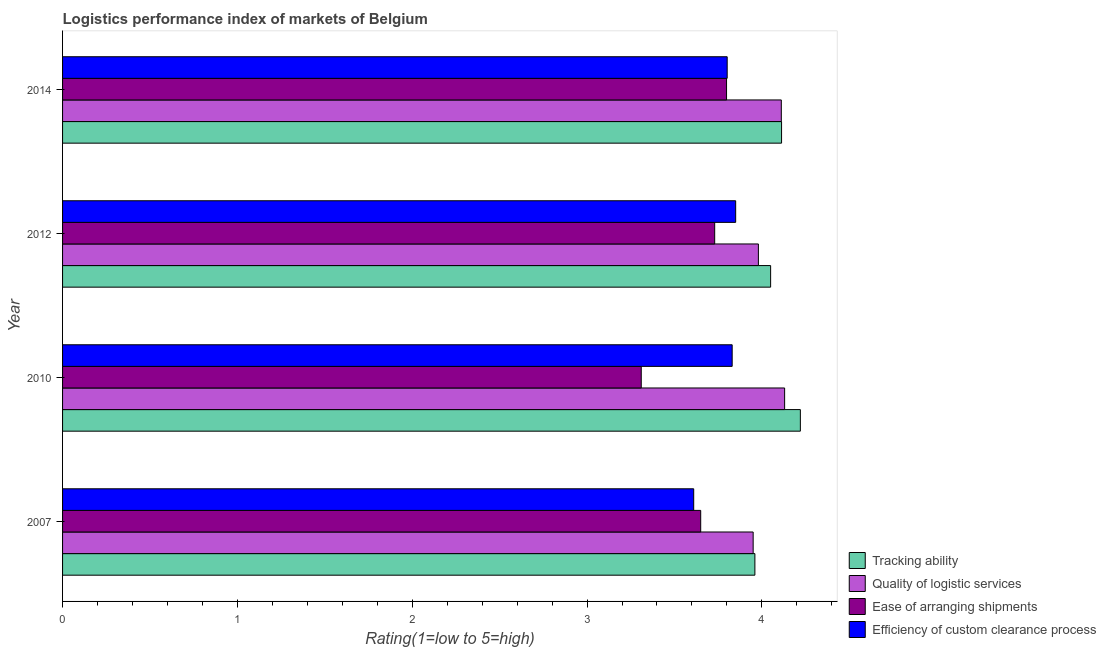Are the number of bars per tick equal to the number of legend labels?
Your answer should be compact. Yes. Are the number of bars on each tick of the Y-axis equal?
Ensure brevity in your answer.  Yes. How many bars are there on the 2nd tick from the bottom?
Provide a succinct answer. 4. In how many cases, is the number of bars for a given year not equal to the number of legend labels?
Offer a terse response. 0. What is the lpi rating of ease of arranging shipments in 2014?
Ensure brevity in your answer.  3.8. Across all years, what is the maximum lpi rating of quality of logistic services?
Provide a succinct answer. 4.13. Across all years, what is the minimum lpi rating of ease of arranging shipments?
Provide a succinct answer. 3.31. In which year was the lpi rating of ease of arranging shipments minimum?
Ensure brevity in your answer.  2010. What is the total lpi rating of quality of logistic services in the graph?
Give a very brief answer. 16.17. What is the difference between the lpi rating of quality of logistic services in 2007 and that in 2012?
Offer a terse response. -0.03. What is the difference between the lpi rating of ease of arranging shipments in 2014 and the lpi rating of tracking ability in 2007?
Make the answer very short. -0.16. What is the average lpi rating of quality of logistic services per year?
Your answer should be very brief. 4.04. In the year 2012, what is the difference between the lpi rating of efficiency of custom clearance process and lpi rating of quality of logistic services?
Make the answer very short. -0.13. In how many years, is the lpi rating of ease of arranging shipments greater than 1.2 ?
Offer a terse response. 4. What is the ratio of the lpi rating of tracking ability in 2010 to that in 2014?
Give a very brief answer. 1.03. Is the difference between the lpi rating of efficiency of custom clearance process in 2012 and 2014 greater than the difference between the lpi rating of ease of arranging shipments in 2012 and 2014?
Your answer should be compact. Yes. What is the difference between the highest and the second highest lpi rating of efficiency of custom clearance process?
Give a very brief answer. 0.02. What is the difference between the highest and the lowest lpi rating of ease of arranging shipments?
Ensure brevity in your answer.  0.49. In how many years, is the lpi rating of tracking ability greater than the average lpi rating of tracking ability taken over all years?
Make the answer very short. 2. Is the sum of the lpi rating of ease of arranging shipments in 2010 and 2014 greater than the maximum lpi rating of tracking ability across all years?
Your answer should be compact. Yes. What does the 4th bar from the top in 2010 represents?
Provide a short and direct response. Tracking ability. What does the 1st bar from the bottom in 2012 represents?
Give a very brief answer. Tracking ability. Is it the case that in every year, the sum of the lpi rating of tracking ability and lpi rating of quality of logistic services is greater than the lpi rating of ease of arranging shipments?
Offer a terse response. Yes. How many bars are there?
Offer a very short reply. 16. How many years are there in the graph?
Offer a terse response. 4. What is the difference between two consecutive major ticks on the X-axis?
Offer a very short reply. 1. Are the values on the major ticks of X-axis written in scientific E-notation?
Provide a short and direct response. No. How many legend labels are there?
Give a very brief answer. 4. What is the title of the graph?
Ensure brevity in your answer.  Logistics performance index of markets of Belgium. What is the label or title of the X-axis?
Give a very brief answer. Rating(1=low to 5=high). What is the label or title of the Y-axis?
Give a very brief answer. Year. What is the Rating(1=low to 5=high) in Tracking ability in 2007?
Provide a short and direct response. 3.96. What is the Rating(1=low to 5=high) of Quality of logistic services in 2007?
Provide a short and direct response. 3.95. What is the Rating(1=low to 5=high) in Ease of arranging shipments in 2007?
Give a very brief answer. 3.65. What is the Rating(1=low to 5=high) of Efficiency of custom clearance process in 2007?
Provide a short and direct response. 3.61. What is the Rating(1=low to 5=high) of Tracking ability in 2010?
Make the answer very short. 4.22. What is the Rating(1=low to 5=high) in Quality of logistic services in 2010?
Ensure brevity in your answer.  4.13. What is the Rating(1=low to 5=high) in Ease of arranging shipments in 2010?
Your answer should be very brief. 3.31. What is the Rating(1=low to 5=high) of Efficiency of custom clearance process in 2010?
Offer a very short reply. 3.83. What is the Rating(1=low to 5=high) in Tracking ability in 2012?
Offer a very short reply. 4.05. What is the Rating(1=low to 5=high) of Quality of logistic services in 2012?
Give a very brief answer. 3.98. What is the Rating(1=low to 5=high) of Ease of arranging shipments in 2012?
Your response must be concise. 3.73. What is the Rating(1=low to 5=high) in Efficiency of custom clearance process in 2012?
Offer a terse response. 3.85. What is the Rating(1=low to 5=high) in Tracking ability in 2014?
Your answer should be very brief. 4.11. What is the Rating(1=low to 5=high) of Quality of logistic services in 2014?
Give a very brief answer. 4.11. What is the Rating(1=low to 5=high) in Ease of arranging shipments in 2014?
Your answer should be very brief. 3.8. What is the Rating(1=low to 5=high) in Efficiency of custom clearance process in 2014?
Provide a succinct answer. 3.8. Across all years, what is the maximum Rating(1=low to 5=high) of Tracking ability?
Provide a succinct answer. 4.22. Across all years, what is the maximum Rating(1=low to 5=high) of Quality of logistic services?
Your answer should be compact. 4.13. Across all years, what is the maximum Rating(1=low to 5=high) of Ease of arranging shipments?
Make the answer very short. 3.8. Across all years, what is the maximum Rating(1=low to 5=high) in Efficiency of custom clearance process?
Your answer should be compact. 3.85. Across all years, what is the minimum Rating(1=low to 5=high) in Tracking ability?
Offer a very short reply. 3.96. Across all years, what is the minimum Rating(1=low to 5=high) of Quality of logistic services?
Your response must be concise. 3.95. Across all years, what is the minimum Rating(1=low to 5=high) in Ease of arranging shipments?
Your response must be concise. 3.31. Across all years, what is the minimum Rating(1=low to 5=high) in Efficiency of custom clearance process?
Offer a terse response. 3.61. What is the total Rating(1=low to 5=high) of Tracking ability in the graph?
Provide a short and direct response. 16.34. What is the total Rating(1=low to 5=high) in Quality of logistic services in the graph?
Give a very brief answer. 16.17. What is the total Rating(1=low to 5=high) in Ease of arranging shipments in the graph?
Offer a very short reply. 14.49. What is the total Rating(1=low to 5=high) of Efficiency of custom clearance process in the graph?
Make the answer very short. 15.09. What is the difference between the Rating(1=low to 5=high) in Tracking ability in 2007 and that in 2010?
Make the answer very short. -0.26. What is the difference between the Rating(1=low to 5=high) of Quality of logistic services in 2007 and that in 2010?
Ensure brevity in your answer.  -0.18. What is the difference between the Rating(1=low to 5=high) of Ease of arranging shipments in 2007 and that in 2010?
Keep it short and to the point. 0.34. What is the difference between the Rating(1=low to 5=high) in Efficiency of custom clearance process in 2007 and that in 2010?
Ensure brevity in your answer.  -0.22. What is the difference between the Rating(1=low to 5=high) of Tracking ability in 2007 and that in 2012?
Make the answer very short. -0.09. What is the difference between the Rating(1=low to 5=high) of Quality of logistic services in 2007 and that in 2012?
Give a very brief answer. -0.03. What is the difference between the Rating(1=low to 5=high) of Ease of arranging shipments in 2007 and that in 2012?
Make the answer very short. -0.08. What is the difference between the Rating(1=low to 5=high) of Efficiency of custom clearance process in 2007 and that in 2012?
Keep it short and to the point. -0.24. What is the difference between the Rating(1=low to 5=high) of Tracking ability in 2007 and that in 2014?
Provide a short and direct response. -0.15. What is the difference between the Rating(1=low to 5=high) of Quality of logistic services in 2007 and that in 2014?
Your answer should be very brief. -0.16. What is the difference between the Rating(1=low to 5=high) of Ease of arranging shipments in 2007 and that in 2014?
Your response must be concise. -0.15. What is the difference between the Rating(1=low to 5=high) of Efficiency of custom clearance process in 2007 and that in 2014?
Give a very brief answer. -0.19. What is the difference between the Rating(1=low to 5=high) of Tracking ability in 2010 and that in 2012?
Make the answer very short. 0.17. What is the difference between the Rating(1=low to 5=high) of Quality of logistic services in 2010 and that in 2012?
Offer a terse response. 0.15. What is the difference between the Rating(1=low to 5=high) in Ease of arranging shipments in 2010 and that in 2012?
Make the answer very short. -0.42. What is the difference between the Rating(1=low to 5=high) of Efficiency of custom clearance process in 2010 and that in 2012?
Offer a very short reply. -0.02. What is the difference between the Rating(1=low to 5=high) in Tracking ability in 2010 and that in 2014?
Keep it short and to the point. 0.11. What is the difference between the Rating(1=low to 5=high) in Quality of logistic services in 2010 and that in 2014?
Your answer should be compact. 0.02. What is the difference between the Rating(1=low to 5=high) in Ease of arranging shipments in 2010 and that in 2014?
Your response must be concise. -0.49. What is the difference between the Rating(1=low to 5=high) in Efficiency of custom clearance process in 2010 and that in 2014?
Make the answer very short. 0.03. What is the difference between the Rating(1=low to 5=high) in Tracking ability in 2012 and that in 2014?
Your answer should be very brief. -0.06. What is the difference between the Rating(1=low to 5=high) of Quality of logistic services in 2012 and that in 2014?
Provide a succinct answer. -0.13. What is the difference between the Rating(1=low to 5=high) of Ease of arranging shipments in 2012 and that in 2014?
Your answer should be compact. -0.07. What is the difference between the Rating(1=low to 5=high) of Efficiency of custom clearance process in 2012 and that in 2014?
Your response must be concise. 0.05. What is the difference between the Rating(1=low to 5=high) in Tracking ability in 2007 and the Rating(1=low to 5=high) in Quality of logistic services in 2010?
Your answer should be compact. -0.17. What is the difference between the Rating(1=low to 5=high) in Tracking ability in 2007 and the Rating(1=low to 5=high) in Ease of arranging shipments in 2010?
Ensure brevity in your answer.  0.65. What is the difference between the Rating(1=low to 5=high) in Tracking ability in 2007 and the Rating(1=low to 5=high) in Efficiency of custom clearance process in 2010?
Your answer should be very brief. 0.13. What is the difference between the Rating(1=low to 5=high) in Quality of logistic services in 2007 and the Rating(1=low to 5=high) in Ease of arranging shipments in 2010?
Provide a succinct answer. 0.64. What is the difference between the Rating(1=low to 5=high) of Quality of logistic services in 2007 and the Rating(1=low to 5=high) of Efficiency of custom clearance process in 2010?
Provide a short and direct response. 0.12. What is the difference between the Rating(1=low to 5=high) in Ease of arranging shipments in 2007 and the Rating(1=low to 5=high) in Efficiency of custom clearance process in 2010?
Make the answer very short. -0.18. What is the difference between the Rating(1=low to 5=high) in Tracking ability in 2007 and the Rating(1=low to 5=high) in Quality of logistic services in 2012?
Your answer should be compact. -0.02. What is the difference between the Rating(1=low to 5=high) in Tracking ability in 2007 and the Rating(1=low to 5=high) in Ease of arranging shipments in 2012?
Provide a succinct answer. 0.23. What is the difference between the Rating(1=low to 5=high) of Tracking ability in 2007 and the Rating(1=low to 5=high) of Efficiency of custom clearance process in 2012?
Your answer should be very brief. 0.11. What is the difference between the Rating(1=low to 5=high) of Quality of logistic services in 2007 and the Rating(1=low to 5=high) of Ease of arranging shipments in 2012?
Give a very brief answer. 0.22. What is the difference between the Rating(1=low to 5=high) in Tracking ability in 2007 and the Rating(1=low to 5=high) in Quality of logistic services in 2014?
Provide a succinct answer. -0.15. What is the difference between the Rating(1=low to 5=high) in Tracking ability in 2007 and the Rating(1=low to 5=high) in Ease of arranging shipments in 2014?
Make the answer very short. 0.16. What is the difference between the Rating(1=low to 5=high) of Tracking ability in 2007 and the Rating(1=low to 5=high) of Efficiency of custom clearance process in 2014?
Your answer should be compact. 0.16. What is the difference between the Rating(1=low to 5=high) of Quality of logistic services in 2007 and the Rating(1=low to 5=high) of Ease of arranging shipments in 2014?
Provide a short and direct response. 0.15. What is the difference between the Rating(1=low to 5=high) in Quality of logistic services in 2007 and the Rating(1=low to 5=high) in Efficiency of custom clearance process in 2014?
Ensure brevity in your answer.  0.15. What is the difference between the Rating(1=low to 5=high) in Ease of arranging shipments in 2007 and the Rating(1=low to 5=high) in Efficiency of custom clearance process in 2014?
Your answer should be compact. -0.15. What is the difference between the Rating(1=low to 5=high) in Tracking ability in 2010 and the Rating(1=low to 5=high) in Quality of logistic services in 2012?
Ensure brevity in your answer.  0.24. What is the difference between the Rating(1=low to 5=high) of Tracking ability in 2010 and the Rating(1=low to 5=high) of Ease of arranging shipments in 2012?
Your response must be concise. 0.49. What is the difference between the Rating(1=low to 5=high) in Tracking ability in 2010 and the Rating(1=low to 5=high) in Efficiency of custom clearance process in 2012?
Your answer should be very brief. 0.37. What is the difference between the Rating(1=low to 5=high) in Quality of logistic services in 2010 and the Rating(1=low to 5=high) in Efficiency of custom clearance process in 2012?
Offer a terse response. 0.28. What is the difference between the Rating(1=low to 5=high) of Ease of arranging shipments in 2010 and the Rating(1=low to 5=high) of Efficiency of custom clearance process in 2012?
Ensure brevity in your answer.  -0.54. What is the difference between the Rating(1=low to 5=high) in Tracking ability in 2010 and the Rating(1=low to 5=high) in Quality of logistic services in 2014?
Offer a terse response. 0.11. What is the difference between the Rating(1=low to 5=high) in Tracking ability in 2010 and the Rating(1=low to 5=high) in Ease of arranging shipments in 2014?
Your response must be concise. 0.42. What is the difference between the Rating(1=low to 5=high) in Tracking ability in 2010 and the Rating(1=low to 5=high) in Efficiency of custom clearance process in 2014?
Offer a terse response. 0.42. What is the difference between the Rating(1=low to 5=high) of Quality of logistic services in 2010 and the Rating(1=low to 5=high) of Ease of arranging shipments in 2014?
Provide a short and direct response. 0.33. What is the difference between the Rating(1=low to 5=high) of Quality of logistic services in 2010 and the Rating(1=low to 5=high) of Efficiency of custom clearance process in 2014?
Your answer should be compact. 0.33. What is the difference between the Rating(1=low to 5=high) in Ease of arranging shipments in 2010 and the Rating(1=low to 5=high) in Efficiency of custom clearance process in 2014?
Your response must be concise. -0.49. What is the difference between the Rating(1=low to 5=high) of Tracking ability in 2012 and the Rating(1=low to 5=high) of Quality of logistic services in 2014?
Keep it short and to the point. -0.06. What is the difference between the Rating(1=low to 5=high) of Tracking ability in 2012 and the Rating(1=low to 5=high) of Ease of arranging shipments in 2014?
Your answer should be very brief. 0.25. What is the difference between the Rating(1=low to 5=high) in Tracking ability in 2012 and the Rating(1=low to 5=high) in Efficiency of custom clearance process in 2014?
Offer a terse response. 0.25. What is the difference between the Rating(1=low to 5=high) of Quality of logistic services in 2012 and the Rating(1=low to 5=high) of Ease of arranging shipments in 2014?
Offer a very short reply. 0.18. What is the difference between the Rating(1=low to 5=high) of Quality of logistic services in 2012 and the Rating(1=low to 5=high) of Efficiency of custom clearance process in 2014?
Offer a very short reply. 0.18. What is the difference between the Rating(1=low to 5=high) in Ease of arranging shipments in 2012 and the Rating(1=low to 5=high) in Efficiency of custom clearance process in 2014?
Ensure brevity in your answer.  -0.07. What is the average Rating(1=low to 5=high) of Tracking ability per year?
Give a very brief answer. 4.09. What is the average Rating(1=low to 5=high) of Quality of logistic services per year?
Provide a succinct answer. 4.04. What is the average Rating(1=low to 5=high) of Ease of arranging shipments per year?
Your response must be concise. 3.62. What is the average Rating(1=low to 5=high) of Efficiency of custom clearance process per year?
Offer a terse response. 3.77. In the year 2007, what is the difference between the Rating(1=low to 5=high) of Tracking ability and Rating(1=low to 5=high) of Quality of logistic services?
Offer a very short reply. 0.01. In the year 2007, what is the difference between the Rating(1=low to 5=high) in Tracking ability and Rating(1=low to 5=high) in Ease of arranging shipments?
Make the answer very short. 0.31. In the year 2007, what is the difference between the Rating(1=low to 5=high) in Quality of logistic services and Rating(1=low to 5=high) in Efficiency of custom clearance process?
Your answer should be compact. 0.34. In the year 2007, what is the difference between the Rating(1=low to 5=high) in Ease of arranging shipments and Rating(1=low to 5=high) in Efficiency of custom clearance process?
Make the answer very short. 0.04. In the year 2010, what is the difference between the Rating(1=low to 5=high) in Tracking ability and Rating(1=low to 5=high) in Quality of logistic services?
Provide a succinct answer. 0.09. In the year 2010, what is the difference between the Rating(1=low to 5=high) of Tracking ability and Rating(1=low to 5=high) of Ease of arranging shipments?
Your response must be concise. 0.91. In the year 2010, what is the difference between the Rating(1=low to 5=high) in Tracking ability and Rating(1=low to 5=high) in Efficiency of custom clearance process?
Keep it short and to the point. 0.39. In the year 2010, what is the difference between the Rating(1=low to 5=high) in Quality of logistic services and Rating(1=low to 5=high) in Ease of arranging shipments?
Your answer should be very brief. 0.82. In the year 2010, what is the difference between the Rating(1=low to 5=high) in Ease of arranging shipments and Rating(1=low to 5=high) in Efficiency of custom clearance process?
Keep it short and to the point. -0.52. In the year 2012, what is the difference between the Rating(1=low to 5=high) in Tracking ability and Rating(1=low to 5=high) in Quality of logistic services?
Give a very brief answer. 0.07. In the year 2012, what is the difference between the Rating(1=low to 5=high) of Tracking ability and Rating(1=low to 5=high) of Ease of arranging shipments?
Offer a terse response. 0.32. In the year 2012, what is the difference between the Rating(1=low to 5=high) in Tracking ability and Rating(1=low to 5=high) in Efficiency of custom clearance process?
Your response must be concise. 0.2. In the year 2012, what is the difference between the Rating(1=low to 5=high) in Quality of logistic services and Rating(1=low to 5=high) in Efficiency of custom clearance process?
Make the answer very short. 0.13. In the year 2012, what is the difference between the Rating(1=low to 5=high) of Ease of arranging shipments and Rating(1=low to 5=high) of Efficiency of custom clearance process?
Your answer should be compact. -0.12. In the year 2014, what is the difference between the Rating(1=low to 5=high) in Tracking ability and Rating(1=low to 5=high) in Quality of logistic services?
Offer a very short reply. 0. In the year 2014, what is the difference between the Rating(1=low to 5=high) of Tracking ability and Rating(1=low to 5=high) of Ease of arranging shipments?
Offer a very short reply. 0.31. In the year 2014, what is the difference between the Rating(1=low to 5=high) of Tracking ability and Rating(1=low to 5=high) of Efficiency of custom clearance process?
Ensure brevity in your answer.  0.31. In the year 2014, what is the difference between the Rating(1=low to 5=high) in Quality of logistic services and Rating(1=low to 5=high) in Ease of arranging shipments?
Give a very brief answer. 0.31. In the year 2014, what is the difference between the Rating(1=low to 5=high) of Quality of logistic services and Rating(1=low to 5=high) of Efficiency of custom clearance process?
Offer a very short reply. 0.31. In the year 2014, what is the difference between the Rating(1=low to 5=high) of Ease of arranging shipments and Rating(1=low to 5=high) of Efficiency of custom clearance process?
Ensure brevity in your answer.  -0. What is the ratio of the Rating(1=low to 5=high) of Tracking ability in 2007 to that in 2010?
Make the answer very short. 0.94. What is the ratio of the Rating(1=low to 5=high) in Quality of logistic services in 2007 to that in 2010?
Your response must be concise. 0.96. What is the ratio of the Rating(1=low to 5=high) in Ease of arranging shipments in 2007 to that in 2010?
Your response must be concise. 1.1. What is the ratio of the Rating(1=low to 5=high) in Efficiency of custom clearance process in 2007 to that in 2010?
Keep it short and to the point. 0.94. What is the ratio of the Rating(1=low to 5=high) in Tracking ability in 2007 to that in 2012?
Your response must be concise. 0.98. What is the ratio of the Rating(1=low to 5=high) in Quality of logistic services in 2007 to that in 2012?
Offer a terse response. 0.99. What is the ratio of the Rating(1=low to 5=high) of Ease of arranging shipments in 2007 to that in 2012?
Your response must be concise. 0.98. What is the ratio of the Rating(1=low to 5=high) of Efficiency of custom clearance process in 2007 to that in 2012?
Keep it short and to the point. 0.94. What is the ratio of the Rating(1=low to 5=high) of Tracking ability in 2007 to that in 2014?
Your response must be concise. 0.96. What is the ratio of the Rating(1=low to 5=high) of Quality of logistic services in 2007 to that in 2014?
Keep it short and to the point. 0.96. What is the ratio of the Rating(1=low to 5=high) in Ease of arranging shipments in 2007 to that in 2014?
Provide a succinct answer. 0.96. What is the ratio of the Rating(1=low to 5=high) in Efficiency of custom clearance process in 2007 to that in 2014?
Make the answer very short. 0.95. What is the ratio of the Rating(1=low to 5=high) in Tracking ability in 2010 to that in 2012?
Provide a succinct answer. 1.04. What is the ratio of the Rating(1=low to 5=high) in Quality of logistic services in 2010 to that in 2012?
Keep it short and to the point. 1.04. What is the ratio of the Rating(1=low to 5=high) in Ease of arranging shipments in 2010 to that in 2012?
Your response must be concise. 0.89. What is the ratio of the Rating(1=low to 5=high) in Tracking ability in 2010 to that in 2014?
Give a very brief answer. 1.03. What is the ratio of the Rating(1=low to 5=high) in Quality of logistic services in 2010 to that in 2014?
Offer a terse response. 1. What is the ratio of the Rating(1=low to 5=high) in Ease of arranging shipments in 2010 to that in 2014?
Give a very brief answer. 0.87. What is the ratio of the Rating(1=low to 5=high) in Efficiency of custom clearance process in 2010 to that in 2014?
Make the answer very short. 1.01. What is the ratio of the Rating(1=low to 5=high) in Quality of logistic services in 2012 to that in 2014?
Provide a short and direct response. 0.97. What is the ratio of the Rating(1=low to 5=high) in Ease of arranging shipments in 2012 to that in 2014?
Your answer should be compact. 0.98. What is the ratio of the Rating(1=low to 5=high) in Efficiency of custom clearance process in 2012 to that in 2014?
Provide a succinct answer. 1.01. What is the difference between the highest and the second highest Rating(1=low to 5=high) of Tracking ability?
Provide a succinct answer. 0.11. What is the difference between the highest and the second highest Rating(1=low to 5=high) in Quality of logistic services?
Ensure brevity in your answer.  0.02. What is the difference between the highest and the second highest Rating(1=low to 5=high) of Ease of arranging shipments?
Provide a succinct answer. 0.07. What is the difference between the highest and the lowest Rating(1=low to 5=high) in Tracking ability?
Offer a terse response. 0.26. What is the difference between the highest and the lowest Rating(1=low to 5=high) of Quality of logistic services?
Your response must be concise. 0.18. What is the difference between the highest and the lowest Rating(1=low to 5=high) in Ease of arranging shipments?
Provide a short and direct response. 0.49. What is the difference between the highest and the lowest Rating(1=low to 5=high) in Efficiency of custom clearance process?
Ensure brevity in your answer.  0.24. 